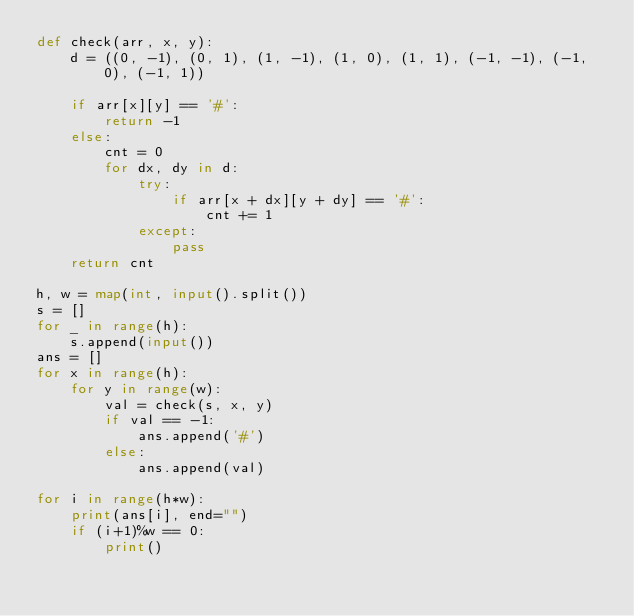Convert code to text. <code><loc_0><loc_0><loc_500><loc_500><_Python_>def check(arr, x, y):
    d = ((0, -1), (0, 1), (1, -1), (1, 0), (1, 1), (-1, -1), (-1, 0), (-1, 1))

    if arr[x][y] == '#':
        return -1
    else:
        cnt = 0
        for dx, dy in d:
            try:
                if arr[x + dx][y + dy] == '#':
                    cnt += 1
            except:
                pass
    return cnt    

h, w = map(int, input().split())
s = []
for _ in range(h):
    s.append(input())
ans = []
for x in range(h):
    for y in range(w):
        val = check(s, x, y)
        if val == -1:
            ans.append('#')
        else:
            ans.append(val)

for i in range(h*w):
    print(ans[i], end="")
    if (i+1)%w == 0:
        print()</code> 